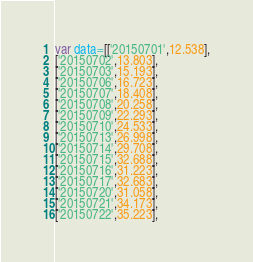<code> <loc_0><loc_0><loc_500><loc_500><_JavaScript_>var data=[['20150701',12.538],
['20150702',13.803],
['20150703',15.193],
['20150706',16.723],
['20150707',18.408],
['20150708',20.258],
['20150709',22.293],
['20150710',24.533],
['20150713',26.998],
['20150714',29.708],
['20150715',32.688],
['20150716',31.223],
['20150717',32.683],
['20150720',31.058],
['20150721',34.173],
['20150722',35.223],</code> 